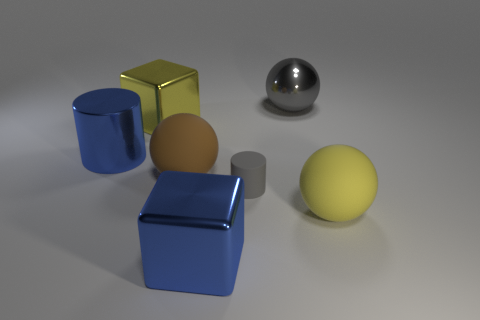Are there any other things that are the same size as the gray cylinder?
Provide a short and direct response. No. There is a brown rubber object on the right side of the cylinder on the left side of the big blue block; are there any tiny gray rubber cylinders that are to the left of it?
Offer a terse response. No. Does the big thing on the right side of the large gray shiny thing have the same shape as the big gray metallic object?
Offer a very short reply. Yes. Is the number of blue blocks behind the brown object greater than the number of large yellow metallic objects?
Your answer should be very brief. No. There is a big shiny cube in front of the small gray thing; is it the same color as the large metal cylinder?
Give a very brief answer. Yes. There is a thing that is in front of the big yellow thing that is in front of the matte ball that is behind the yellow matte thing; what color is it?
Keep it short and to the point. Blue. Do the brown matte ball and the gray sphere have the same size?
Give a very brief answer. Yes. What number of blue shiny things are the same size as the yellow metallic cube?
Keep it short and to the point. 2. What is the shape of the object that is the same color as the big metal cylinder?
Offer a terse response. Cube. Is the material of the block in front of the large brown thing the same as the gray thing that is in front of the yellow cube?
Provide a short and direct response. No. 